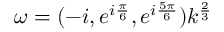<formula> <loc_0><loc_0><loc_500><loc_500>\omega = ( - i , e ^ { i \frac { \pi } { 6 } } , e ^ { i \frac { 5 \pi } { 6 } } ) k ^ { \frac { 2 } { 3 } }</formula> 